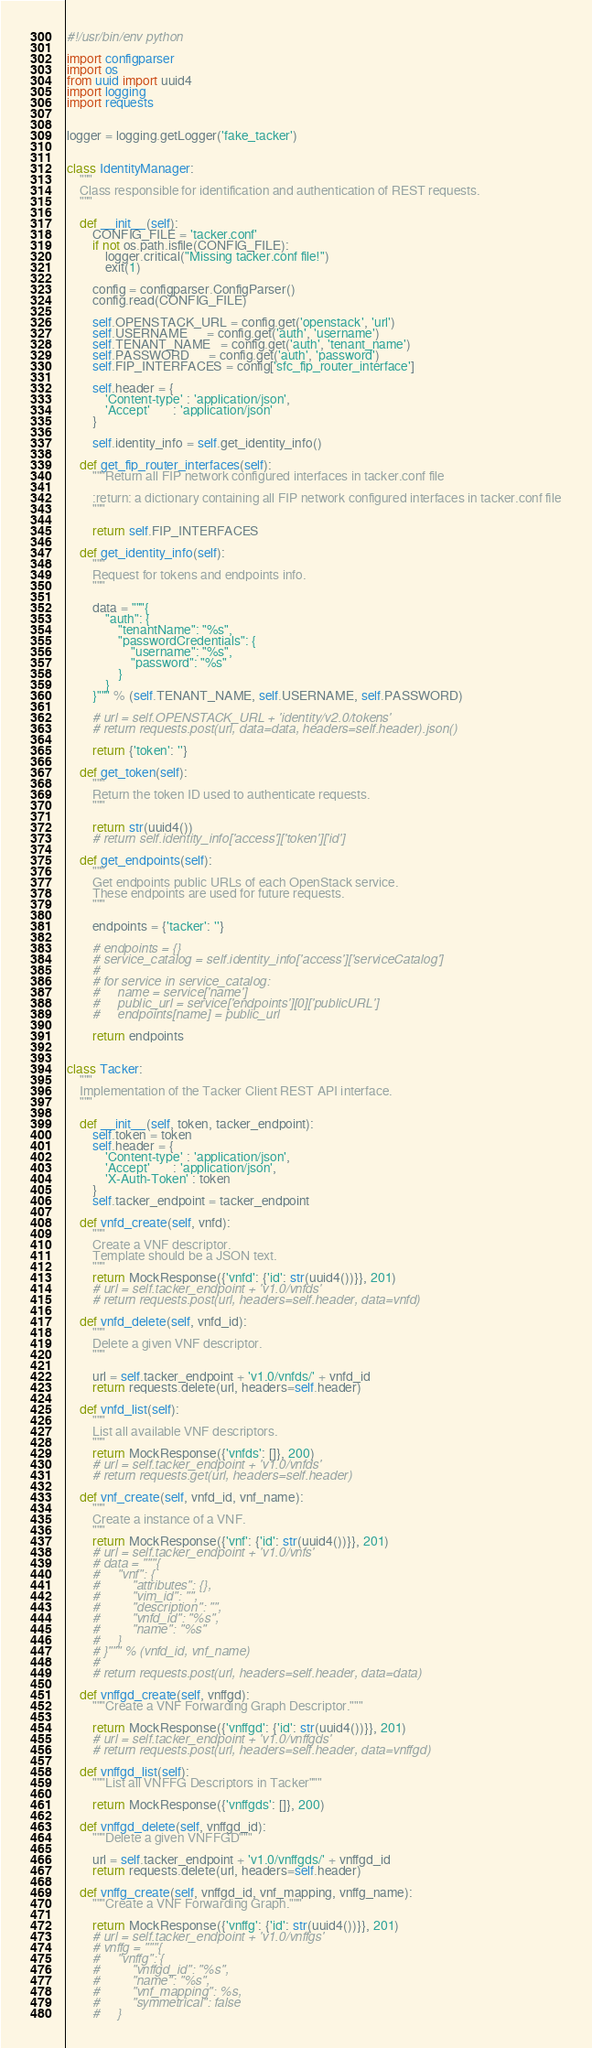<code> <loc_0><loc_0><loc_500><loc_500><_Python_>#!/usr/bin/env python

import configparser
import os
from uuid import uuid4
import logging
import requests


logger = logging.getLogger('fake_tacker')


class IdentityManager:
    """
    Class responsible for identification and authentication of REST requests.
    """

    def __init__(self):
        CONFIG_FILE = 'tacker.conf'
        if not os.path.isfile(CONFIG_FILE):
            logger.critical("Missing tacker.conf file!")
            exit(1)

        config = configparser.ConfigParser()
        config.read(CONFIG_FILE)

        self.OPENSTACK_URL = config.get('openstack', 'url')
        self.USERNAME      = config.get('auth', 'username')
        self.TENANT_NAME   = config.get('auth', 'tenant_name')
        self.PASSWORD      = config.get('auth', 'password')
        self.FIP_INTERFACES = config['sfc_fip_router_interface']

        self.header = {
            'Content-type' : 'application/json',
            'Accept'       : 'application/json'
        }

        self.identity_info = self.get_identity_info()

    def get_fip_router_interfaces(self):
        """Return all FIP network configured interfaces in tacker.conf file

        :return: a dictionary containing all FIP network configured interfaces in tacker.conf file
        """

        return self.FIP_INTERFACES

    def get_identity_info(self):
        """
        Request for tokens and endpoints info.
        """

        data = """{
            "auth": {
                "tenantName": "%s",
                "passwordCredentials": {
                    "username": "%s",
                    "password": "%s"
                }
            }
        }""" % (self.TENANT_NAME, self.USERNAME, self.PASSWORD)

        # url = self.OPENSTACK_URL + 'identity/v2.0/tokens'
        # return requests.post(url, data=data, headers=self.header).json()

        return {'token': ''}

    def get_token(self):
        """
        Return the token ID used to authenticate requests.
        """

        return str(uuid4())
        # return self.identity_info['access']['token']['id']

    def get_endpoints(self):
        """
        Get endpoints public URLs of each OpenStack service.
        These endpoints are used for future requests.
        """

        endpoints = {'tacker': ''}

        # endpoints = {}
        # service_catalog = self.identity_info['access']['serviceCatalog']
        #
        # for service in service_catalog:
        #     name = service['name']
        #     public_url = service['endpoints'][0]['publicURL']
        #     endpoints[name] = public_url

        return endpoints


class Tacker:
    """
    Implementation of the Tacker Client REST API interface.
    """

    def __init__(self, token, tacker_endpoint):
        self.token = token
        self.header = {
            'Content-type' : 'application/json',
            'Accept'       : 'application/json',
            'X-Auth-Token' : token
        }
        self.tacker_endpoint = tacker_endpoint

    def vnfd_create(self, vnfd):
        """
        Create a VNF descriptor.
        Template should be a JSON text.
        """
        return MockResponse({'vnfd': {'id': str(uuid4())}}, 201)
        # url = self.tacker_endpoint + 'v1.0/vnfds'
        # return requests.post(url, headers=self.header, data=vnfd)

    def vnfd_delete(self, vnfd_id):
        """
        Delete a given VNF descriptor.
        """

        url = self.tacker_endpoint + 'v1.0/vnfds/' + vnfd_id
        return requests.delete(url, headers=self.header)

    def vnfd_list(self):
        """
        List all available VNF descriptors.
        """
        return MockResponse({'vnfds': []}, 200)
        # url = self.tacker_endpoint + 'v1.0/vnfds'
        # return requests.get(url, headers=self.header)

    def vnf_create(self, vnfd_id, vnf_name):
        """
        Create a instance of a VNF.
        """
        return MockResponse({'vnf': {'id': str(uuid4())}}, 201)
        # url = self.tacker_endpoint + 'v1.0/vnfs'
        # data = """{
        #     "vnf": {
        #         "attributes": {},
        #         "vim_id": "",
        #         "description": "",
        #         "vnfd_id": "%s",
        #         "name": "%s"
        #     }
        # }""" % (vnfd_id, vnf_name)
        #
        # return requests.post(url, headers=self.header, data=data)

    def vnffgd_create(self, vnffgd):
        """Create a VNF Forwarding Graph Descriptor."""

        return MockResponse({'vnffgd': {'id': str(uuid4())}}, 201)
        # url = self.tacker_endpoint + 'v1.0/vnffgds'
        # return requests.post(url, headers=self.header, data=vnffgd)

    def vnffgd_list(self):
        """List all VNFFG Descriptors in Tacker"""

        return MockResponse({'vnffgds': []}, 200)

    def vnffgd_delete(self, vnffgd_id):
        """Delete a given VNFFGD"""

        url = self.tacker_endpoint + 'v1.0/vnffgds/' + vnffgd_id
        return requests.delete(url, headers=self.header)

    def vnffg_create(self, vnffgd_id, vnf_mapping, vnffg_name):
        """Create a VNF Forwarding Graph."""

        return MockResponse({'vnffg': {'id': str(uuid4())}}, 201)
        # url = self.tacker_endpoint + 'v1.0/vnffgs'
        # vnffg = """{
        #     "vnffg": {
        #         "vnffgd_id": "%s",
        #         "name": "%s",
        #         "vnf_mapping": %s,
        #         "symmetrical": false
        #     }</code> 